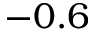<formula> <loc_0><loc_0><loc_500><loc_500>- 0 . 6</formula> 